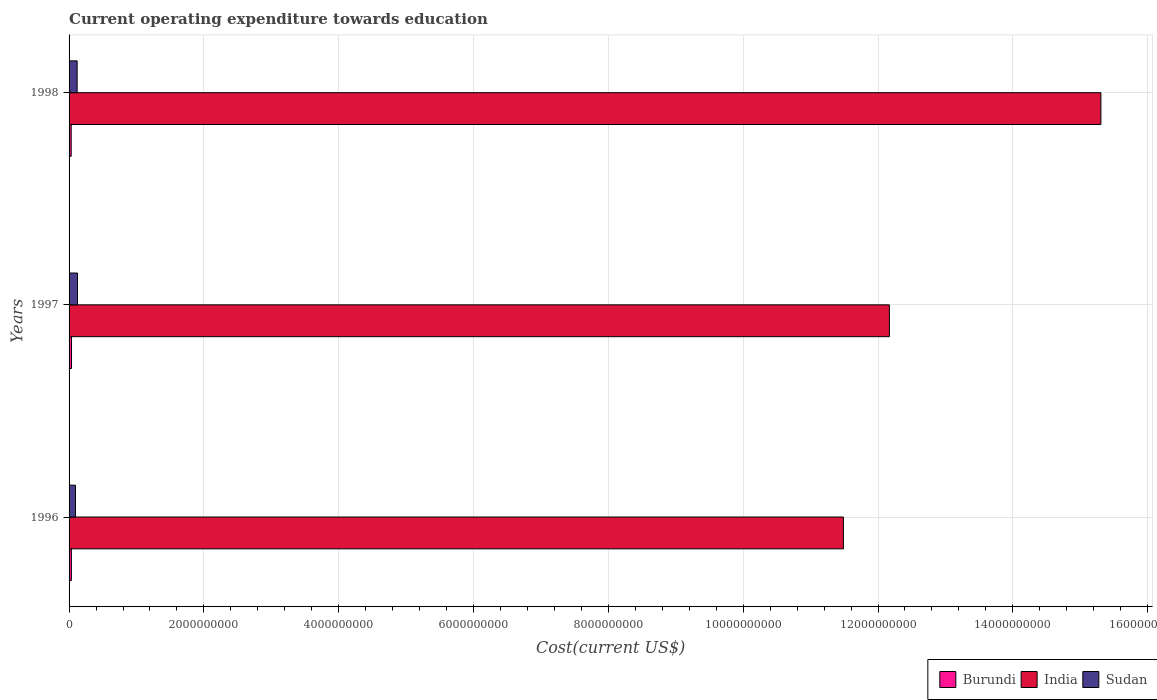How many groups of bars are there?
Your answer should be very brief. 3. In how many cases, is the number of bars for a given year not equal to the number of legend labels?
Offer a terse response. 0. What is the expenditure towards education in India in 1998?
Ensure brevity in your answer.  1.53e+1. Across all years, what is the maximum expenditure towards education in Burundi?
Give a very brief answer. 3.62e+07. Across all years, what is the minimum expenditure towards education in Burundi?
Your response must be concise. 3.13e+07. In which year was the expenditure towards education in Burundi minimum?
Give a very brief answer. 1998. What is the total expenditure towards education in Sudan in the graph?
Give a very brief answer. 3.40e+08. What is the difference between the expenditure towards education in Burundi in 1996 and that in 1997?
Ensure brevity in your answer.  -1.97e+06. What is the difference between the expenditure towards education in Sudan in 1998 and the expenditure towards education in India in 1997?
Your answer should be compact. -1.20e+1. What is the average expenditure towards education in Burundi per year?
Give a very brief answer. 3.39e+07. In the year 1997, what is the difference between the expenditure towards education in Sudan and expenditure towards education in India?
Your response must be concise. -1.20e+1. In how many years, is the expenditure towards education in Sudan greater than 6800000000 US$?
Ensure brevity in your answer.  0. What is the ratio of the expenditure towards education in India in 1996 to that in 1998?
Your answer should be compact. 0.75. Is the expenditure towards education in Burundi in 1996 less than that in 1997?
Give a very brief answer. Yes. What is the difference between the highest and the second highest expenditure towards education in Burundi?
Make the answer very short. 1.97e+06. What is the difference between the highest and the lowest expenditure towards education in India?
Provide a succinct answer. 3.82e+09. What does the 3rd bar from the top in 1996 represents?
Keep it short and to the point. Burundi. What does the 3rd bar from the bottom in 1996 represents?
Your answer should be compact. Sudan. Is it the case that in every year, the sum of the expenditure towards education in Burundi and expenditure towards education in Sudan is greater than the expenditure towards education in India?
Give a very brief answer. No. How many bars are there?
Keep it short and to the point. 9. Are all the bars in the graph horizontal?
Your response must be concise. Yes. Where does the legend appear in the graph?
Offer a very short reply. Bottom right. How are the legend labels stacked?
Ensure brevity in your answer.  Horizontal. What is the title of the graph?
Provide a succinct answer. Current operating expenditure towards education. Does "Bermuda" appear as one of the legend labels in the graph?
Your answer should be very brief. No. What is the label or title of the X-axis?
Your answer should be compact. Cost(current US$). What is the Cost(current US$) in Burundi in 1996?
Offer a terse response. 3.42e+07. What is the Cost(current US$) of India in 1996?
Your answer should be compact. 1.15e+1. What is the Cost(current US$) in Sudan in 1996?
Your answer should be very brief. 9.53e+07. What is the Cost(current US$) of Burundi in 1997?
Your response must be concise. 3.62e+07. What is the Cost(current US$) in India in 1997?
Your answer should be very brief. 1.22e+1. What is the Cost(current US$) in Sudan in 1997?
Provide a succinct answer. 1.25e+08. What is the Cost(current US$) in Burundi in 1998?
Keep it short and to the point. 3.13e+07. What is the Cost(current US$) of India in 1998?
Offer a very short reply. 1.53e+1. What is the Cost(current US$) of Sudan in 1998?
Ensure brevity in your answer.  1.20e+08. Across all years, what is the maximum Cost(current US$) in Burundi?
Your answer should be compact. 3.62e+07. Across all years, what is the maximum Cost(current US$) in India?
Your answer should be compact. 1.53e+1. Across all years, what is the maximum Cost(current US$) of Sudan?
Your answer should be very brief. 1.25e+08. Across all years, what is the minimum Cost(current US$) in Burundi?
Offer a very short reply. 3.13e+07. Across all years, what is the minimum Cost(current US$) in India?
Ensure brevity in your answer.  1.15e+1. Across all years, what is the minimum Cost(current US$) of Sudan?
Offer a very short reply. 9.53e+07. What is the total Cost(current US$) in Burundi in the graph?
Make the answer very short. 1.02e+08. What is the total Cost(current US$) of India in the graph?
Offer a terse response. 3.90e+1. What is the total Cost(current US$) of Sudan in the graph?
Offer a terse response. 3.40e+08. What is the difference between the Cost(current US$) of Burundi in 1996 and that in 1997?
Your response must be concise. -1.97e+06. What is the difference between the Cost(current US$) of India in 1996 and that in 1997?
Provide a short and direct response. -6.82e+08. What is the difference between the Cost(current US$) of Sudan in 1996 and that in 1997?
Offer a terse response. -2.94e+07. What is the difference between the Cost(current US$) of Burundi in 1996 and that in 1998?
Ensure brevity in your answer.  2.92e+06. What is the difference between the Cost(current US$) in India in 1996 and that in 1998?
Offer a terse response. -3.82e+09. What is the difference between the Cost(current US$) in Sudan in 1996 and that in 1998?
Give a very brief answer. -2.44e+07. What is the difference between the Cost(current US$) of Burundi in 1997 and that in 1998?
Your answer should be very brief. 4.89e+06. What is the difference between the Cost(current US$) in India in 1997 and that in 1998?
Provide a short and direct response. -3.14e+09. What is the difference between the Cost(current US$) of Sudan in 1997 and that in 1998?
Your response must be concise. 4.99e+06. What is the difference between the Cost(current US$) of Burundi in 1996 and the Cost(current US$) of India in 1997?
Your response must be concise. -1.21e+1. What is the difference between the Cost(current US$) in Burundi in 1996 and the Cost(current US$) in Sudan in 1997?
Your response must be concise. -9.05e+07. What is the difference between the Cost(current US$) in India in 1996 and the Cost(current US$) in Sudan in 1997?
Your response must be concise. 1.14e+1. What is the difference between the Cost(current US$) in Burundi in 1996 and the Cost(current US$) in India in 1998?
Ensure brevity in your answer.  -1.53e+1. What is the difference between the Cost(current US$) of Burundi in 1996 and the Cost(current US$) of Sudan in 1998?
Your answer should be very brief. -8.55e+07. What is the difference between the Cost(current US$) in India in 1996 and the Cost(current US$) in Sudan in 1998?
Give a very brief answer. 1.14e+1. What is the difference between the Cost(current US$) in Burundi in 1997 and the Cost(current US$) in India in 1998?
Offer a very short reply. -1.53e+1. What is the difference between the Cost(current US$) in Burundi in 1997 and the Cost(current US$) in Sudan in 1998?
Your answer should be compact. -8.35e+07. What is the difference between the Cost(current US$) of India in 1997 and the Cost(current US$) of Sudan in 1998?
Your answer should be very brief. 1.20e+1. What is the average Cost(current US$) of Burundi per year?
Make the answer very short. 3.39e+07. What is the average Cost(current US$) in India per year?
Your answer should be very brief. 1.30e+1. What is the average Cost(current US$) in Sudan per year?
Keep it short and to the point. 1.13e+08. In the year 1996, what is the difference between the Cost(current US$) of Burundi and Cost(current US$) of India?
Offer a very short reply. -1.15e+1. In the year 1996, what is the difference between the Cost(current US$) in Burundi and Cost(current US$) in Sudan?
Provide a short and direct response. -6.11e+07. In the year 1996, what is the difference between the Cost(current US$) of India and Cost(current US$) of Sudan?
Offer a very short reply. 1.14e+1. In the year 1997, what is the difference between the Cost(current US$) in Burundi and Cost(current US$) in India?
Your response must be concise. -1.21e+1. In the year 1997, what is the difference between the Cost(current US$) in Burundi and Cost(current US$) in Sudan?
Provide a short and direct response. -8.85e+07. In the year 1997, what is the difference between the Cost(current US$) of India and Cost(current US$) of Sudan?
Give a very brief answer. 1.20e+1. In the year 1998, what is the difference between the Cost(current US$) of Burundi and Cost(current US$) of India?
Provide a succinct answer. -1.53e+1. In the year 1998, what is the difference between the Cost(current US$) in Burundi and Cost(current US$) in Sudan?
Ensure brevity in your answer.  -8.84e+07. In the year 1998, what is the difference between the Cost(current US$) of India and Cost(current US$) of Sudan?
Give a very brief answer. 1.52e+1. What is the ratio of the Cost(current US$) in Burundi in 1996 to that in 1997?
Make the answer very short. 0.95. What is the ratio of the Cost(current US$) in India in 1996 to that in 1997?
Your answer should be very brief. 0.94. What is the ratio of the Cost(current US$) of Sudan in 1996 to that in 1997?
Offer a very short reply. 0.76. What is the ratio of the Cost(current US$) of Burundi in 1996 to that in 1998?
Provide a succinct answer. 1.09. What is the ratio of the Cost(current US$) in India in 1996 to that in 1998?
Provide a short and direct response. 0.75. What is the ratio of the Cost(current US$) of Sudan in 1996 to that in 1998?
Provide a succinct answer. 0.8. What is the ratio of the Cost(current US$) in Burundi in 1997 to that in 1998?
Ensure brevity in your answer.  1.16. What is the ratio of the Cost(current US$) of India in 1997 to that in 1998?
Provide a short and direct response. 0.8. What is the ratio of the Cost(current US$) of Sudan in 1997 to that in 1998?
Provide a succinct answer. 1.04. What is the difference between the highest and the second highest Cost(current US$) of Burundi?
Provide a succinct answer. 1.97e+06. What is the difference between the highest and the second highest Cost(current US$) in India?
Your answer should be very brief. 3.14e+09. What is the difference between the highest and the second highest Cost(current US$) in Sudan?
Your answer should be compact. 4.99e+06. What is the difference between the highest and the lowest Cost(current US$) in Burundi?
Ensure brevity in your answer.  4.89e+06. What is the difference between the highest and the lowest Cost(current US$) of India?
Give a very brief answer. 3.82e+09. What is the difference between the highest and the lowest Cost(current US$) of Sudan?
Provide a succinct answer. 2.94e+07. 